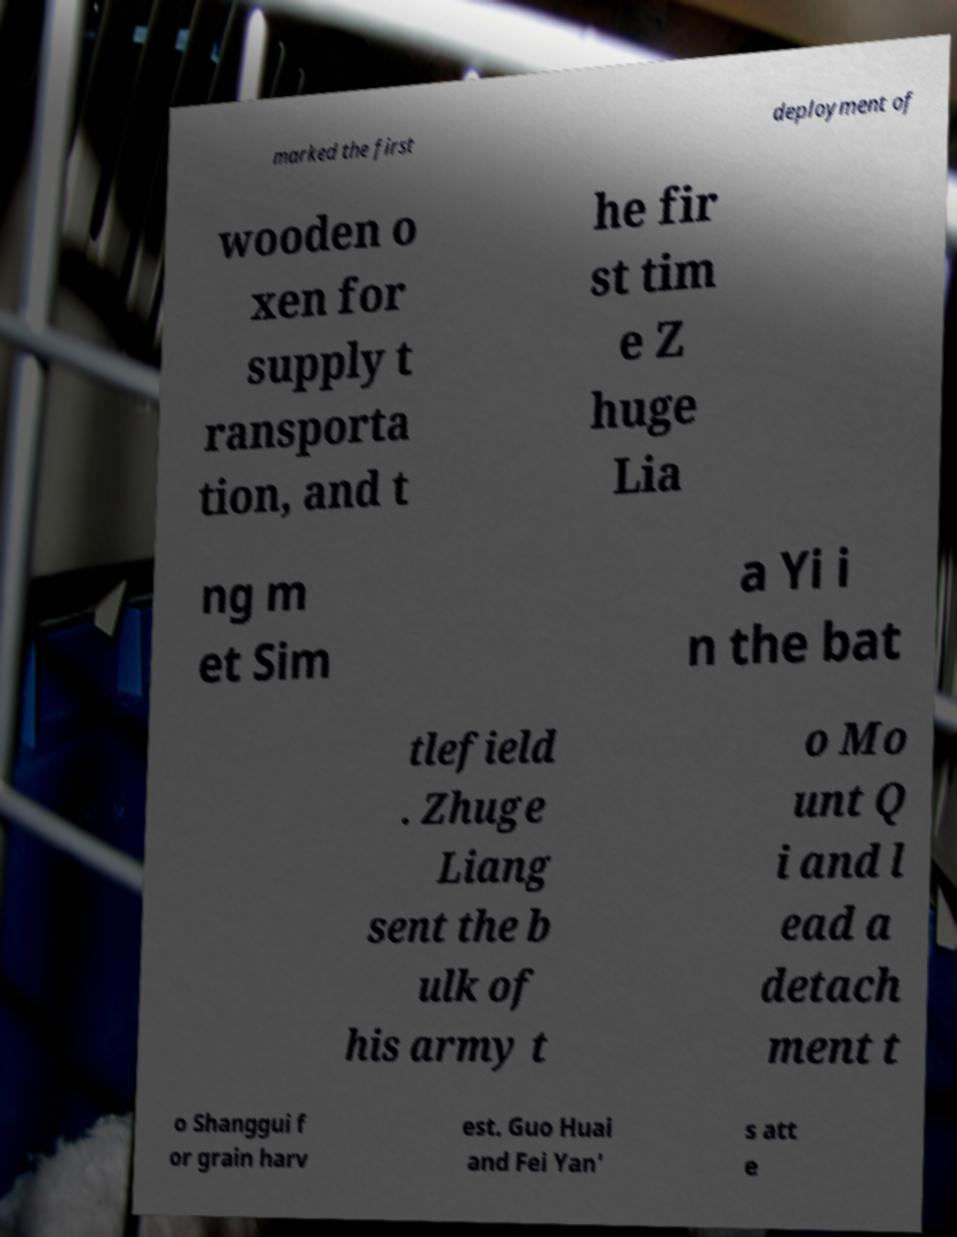For documentation purposes, I need the text within this image transcribed. Could you provide that? marked the first deployment of wooden o xen for supply t ransporta tion, and t he fir st tim e Z huge Lia ng m et Sim a Yi i n the bat tlefield . Zhuge Liang sent the b ulk of his army t o Mo unt Q i and l ead a detach ment t o Shanggui f or grain harv est. Guo Huai and Fei Yan' s att e 